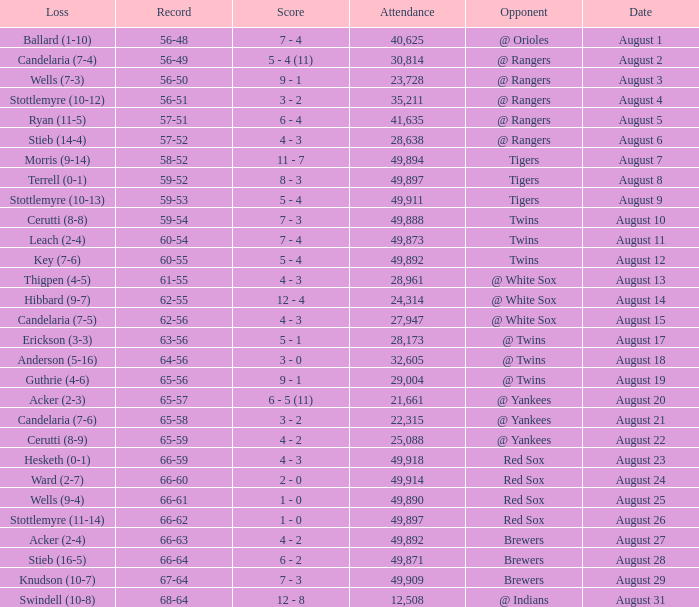What was the record of the game that had a loss of Stottlemyre (10-12)? 56-51. 